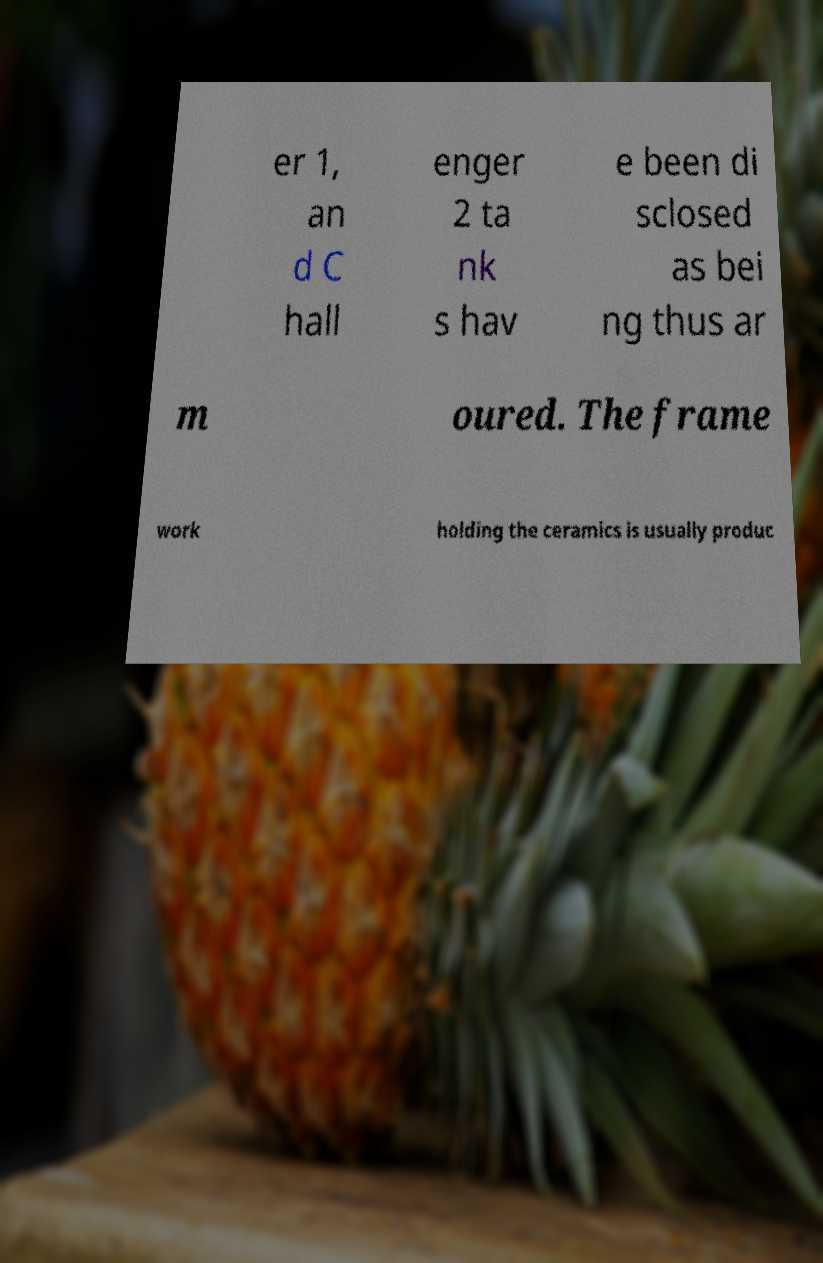Can you read and provide the text displayed in the image?This photo seems to have some interesting text. Can you extract and type it out for me? er 1, an d C hall enger 2 ta nk s hav e been di sclosed as bei ng thus ar m oured. The frame work holding the ceramics is usually produc 